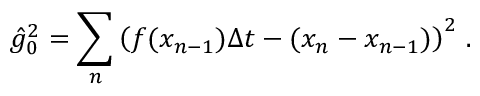<formula> <loc_0><loc_0><loc_500><loc_500>\hat { g } _ { 0 } ^ { 2 } = \sum _ { n } \left ( f ( x _ { n - 1 } ) \Delta t - ( x _ { n } - x _ { n - 1 } ) \right ) ^ { 2 } \, .</formula> 